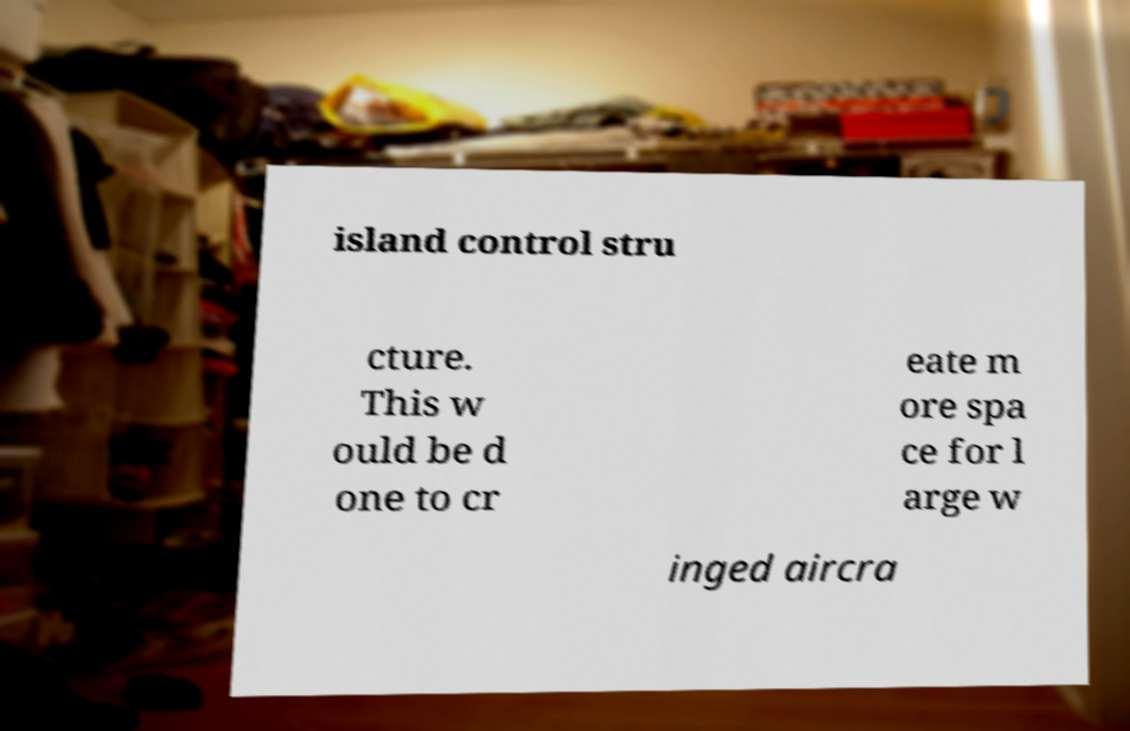I need the written content from this picture converted into text. Can you do that? island control stru cture. This w ould be d one to cr eate m ore spa ce for l arge w inged aircra 